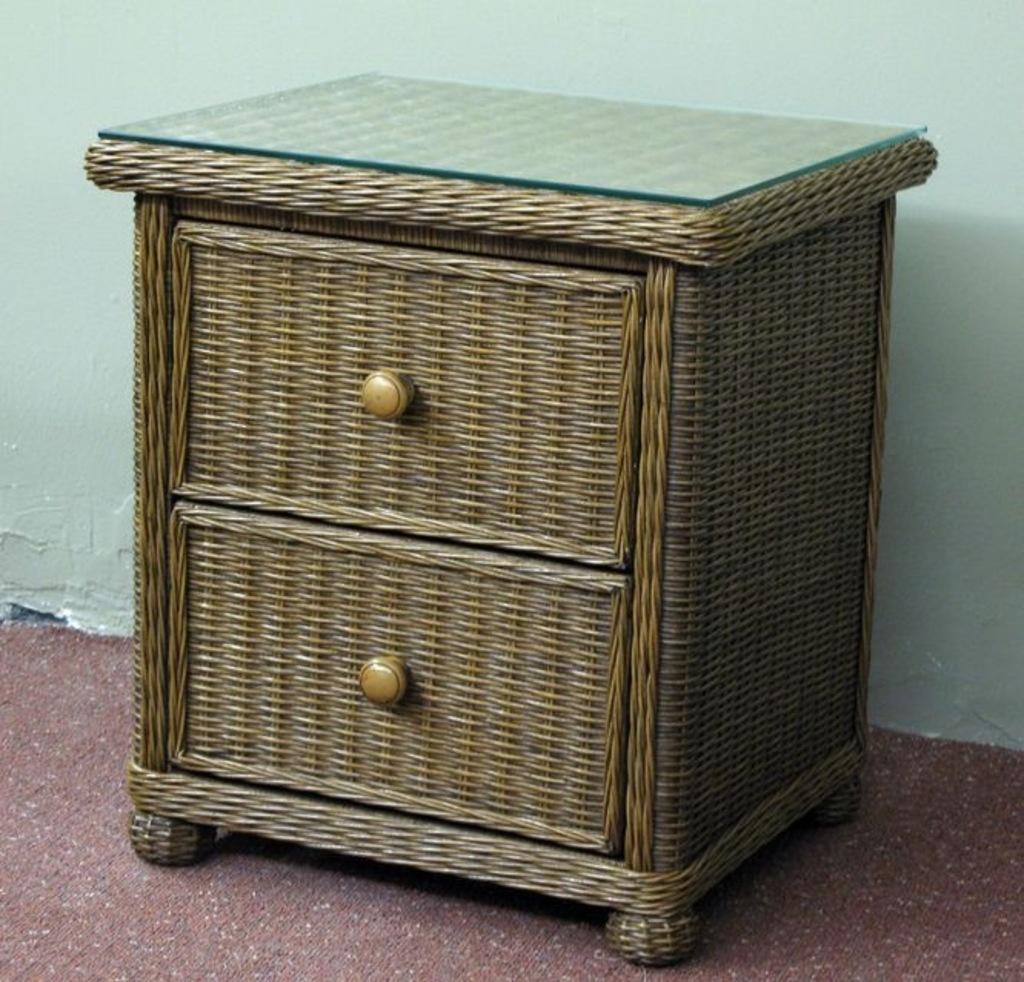In one or two sentences, can you explain what this image depicts? In the image we can see a wooden drover, on it there is a glass sheet. Here we can see the floor and the wall. 